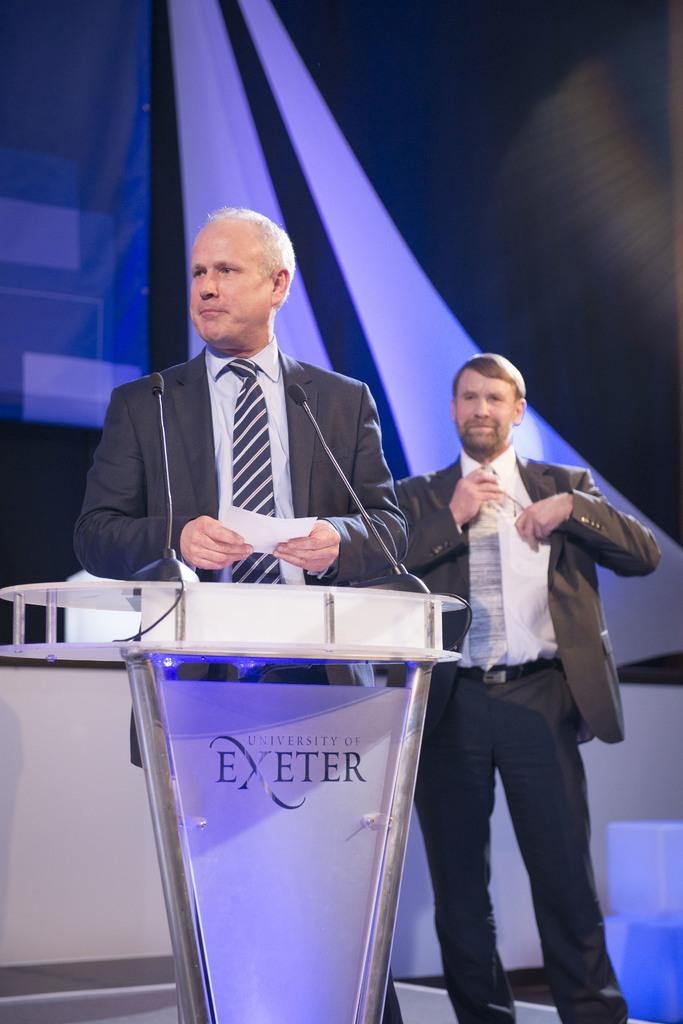<image>
Describe the image concisely. Two men on a stage both in gray suits as one stands at a dias with the words EXETER on platform. 